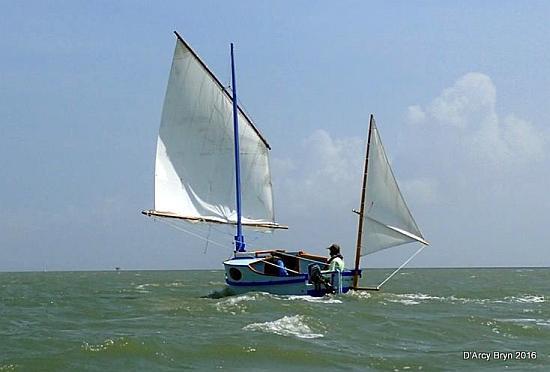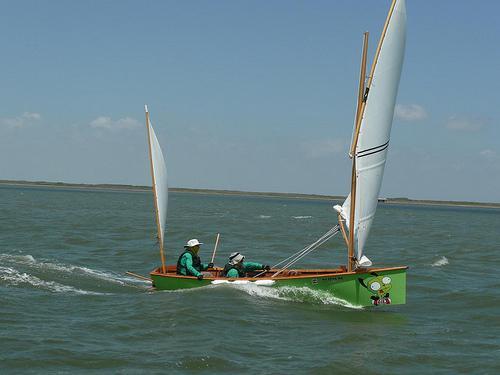The first image is the image on the left, the second image is the image on the right. Evaluate the accuracy of this statement regarding the images: "All the boats are heading in the same direction.". Is it true? Answer yes or no. No. 